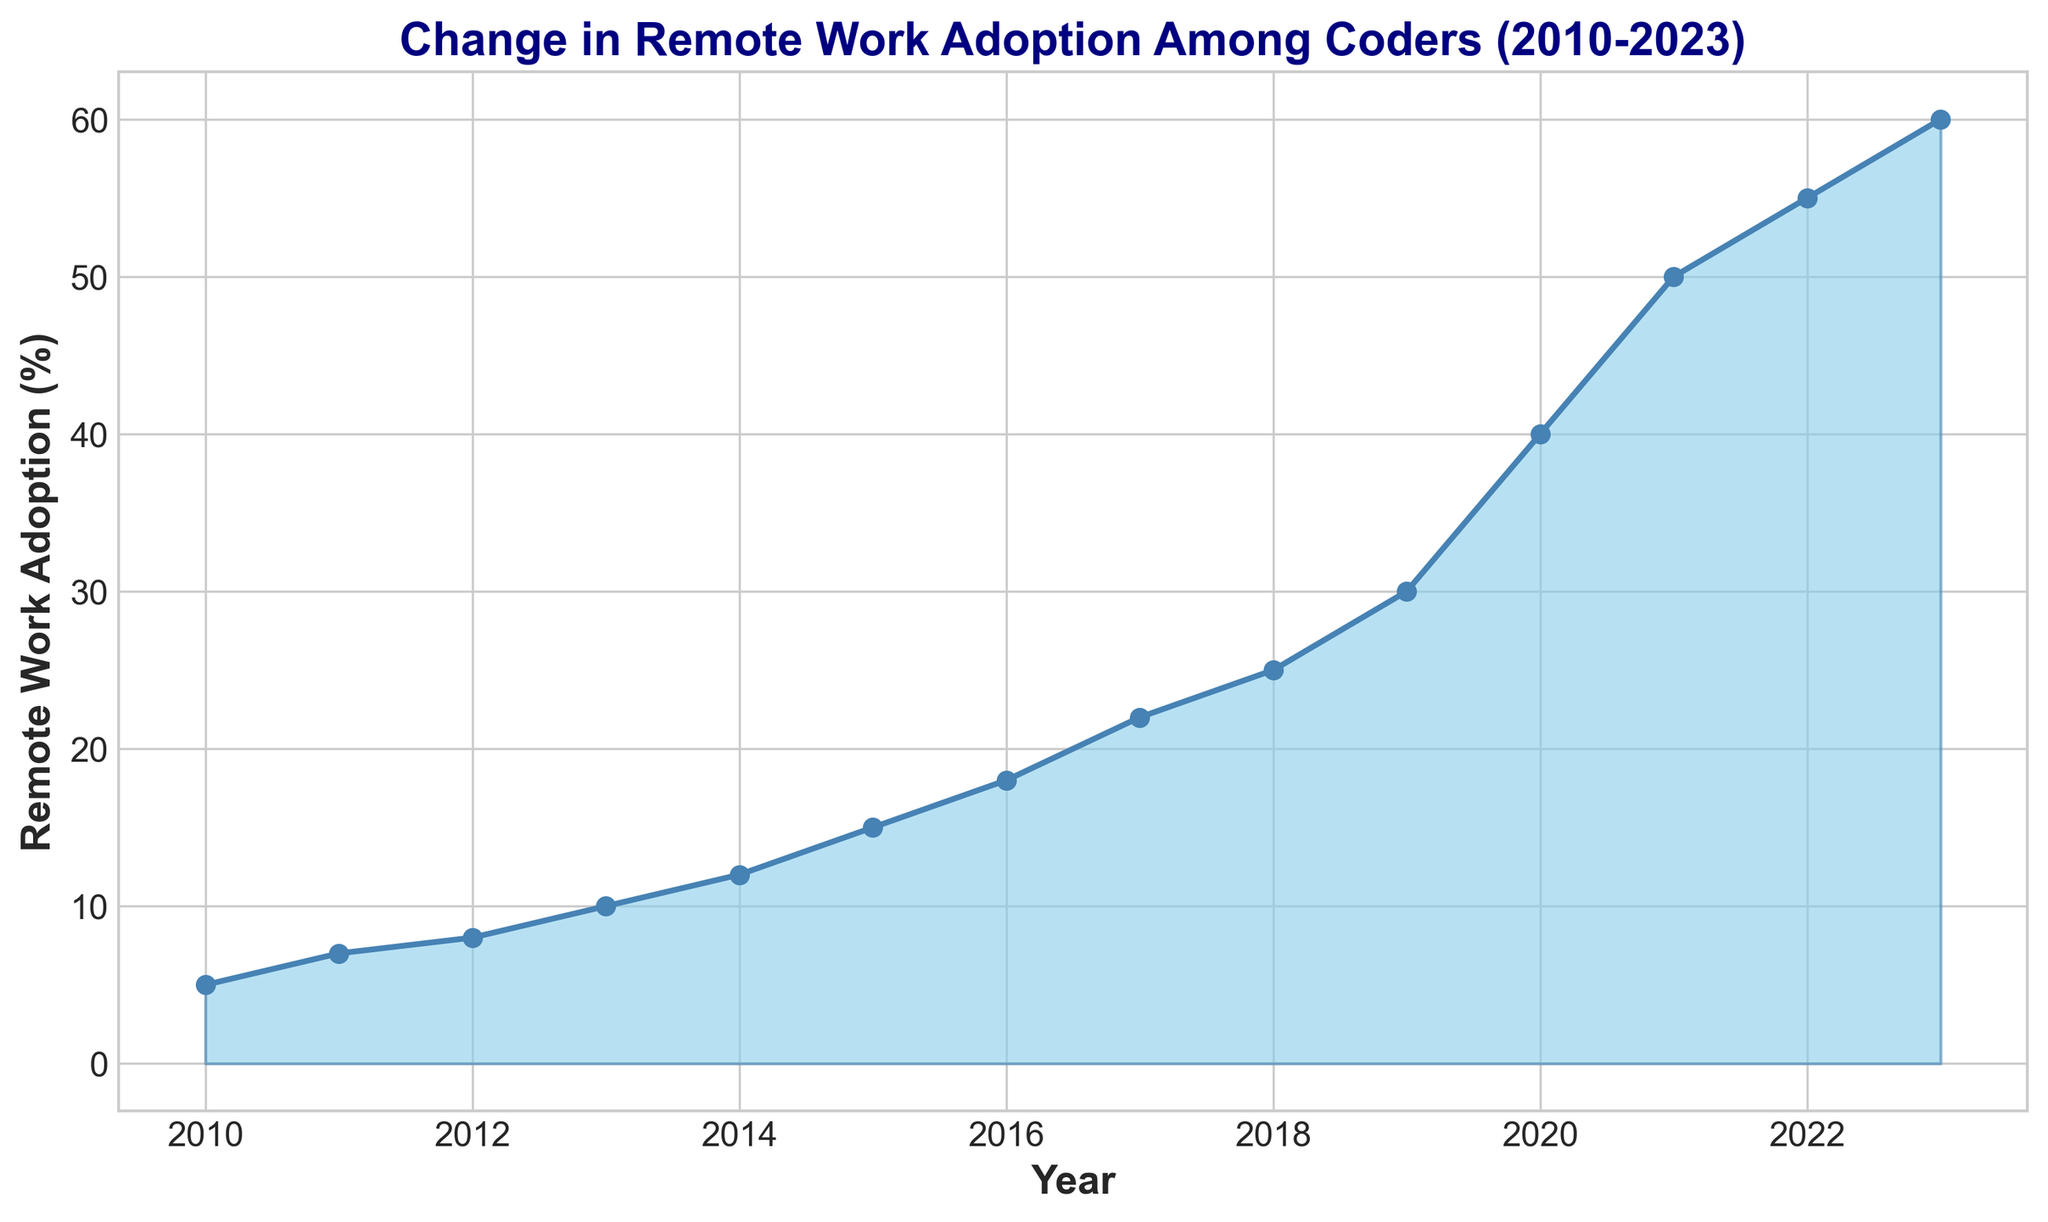what is the overall trend of remote work adoption among coders from 2010 to 2023? The figure shows that remote work adoption among coders has generally increased over the years. Specifically, the adoption rate started at 5% in 2010 and has risen consistently to reach 60% in 2023.
Answer: Increasing Which year saw the sharpest increase in remote work adoption? By comparing the year-to-year increases in adoption rates, we see the biggest jump happened from 2019 to 2020, where the rate went from 30% to 40%.
Answer: 2019 to 2020 How much did remote work adoption among coders increase between 2015 and 2020? The adoption rate in 2015 was 15%, and it increased to 40% by 2020. The difference is calculated by subtracting the 2015 rate from the 2020 rate: 40% - 15% = 25%.
Answer: 25% By how much did remote work adoption change on average per year from 2013 to 2023? The adoption rate in 2013 was 10%, and it increased to 60% by 2023. Over these 10 years, the total change was 60% - 10% = 50%. The average yearly change is 50%/10 years = 5% per year.
Answer: 5% In which years did the remote work adoption exceed the halfway mark of 50%? The figure shows that the adoption rate exceeded 50% in the years 2022 (55%) and 2023 (60%).
Answer: 2022 and 2023 Compare the adoption rate in 2011 and 2017. Which year had a higher rate? The figure shows that the adoption rate in 2011 was 7%, whereas in 2017 it was 22%. Therefore, 2017 had a higher rate.
Answer: 2017 What is the difference in the adoption rate between the start and end of the given timeframe? In 2010, the adoption rate was 5%, and in 2023 it was 60%. The difference is calculated as 60% - 5% = 55%.
Answer: 55% What is the total increase in remote work adoption from 2018 to 2021? In 2018, the adoption rate was 25% and it rose to 50% by 2021. The total increase is 50% - 25% = 25%.
Answer: 25% From the shape and color attributes of the plot, how does the area representing the adoption rate change over time? The filled area under the line graph gradually becomes larger and changes color intensity, with the area starting from a small region in 2010 to a much larger and darker region by 2023, indicating an increase in remote work adoption over time.
Answer: Gradually increases and darkens Which period shows relatively stable growth in remote work adoption without any sharp spikes? The period from 2012 (8%) to 2016 (18%) shows a relatively stable and gradual increase in remote work adoption without sharp spikes, averaging around a 2-3% increase per year.
Answer: 2012 to 2016 